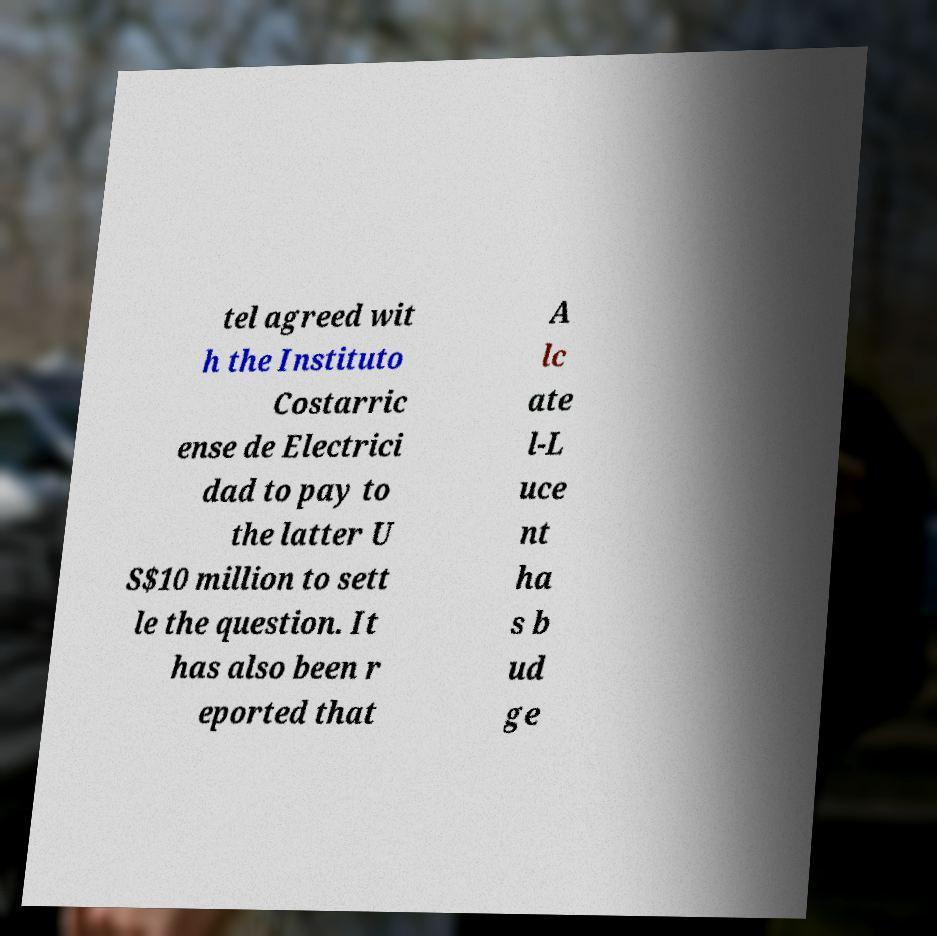What messages or text are displayed in this image? I need them in a readable, typed format. tel agreed wit h the Instituto Costarric ense de Electrici dad to pay to the latter U S$10 million to sett le the question. It has also been r eported that A lc ate l-L uce nt ha s b ud ge 